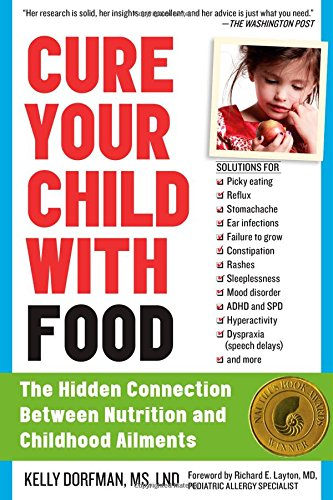What specific conditions does this book address in relation to child health? This book addresses a range of children's health issues related to nutrition including picky eating, reflux, stomachaches, ear infections, constipation, rashes, and more, aiming to provide dietary solutions for these conditions. 